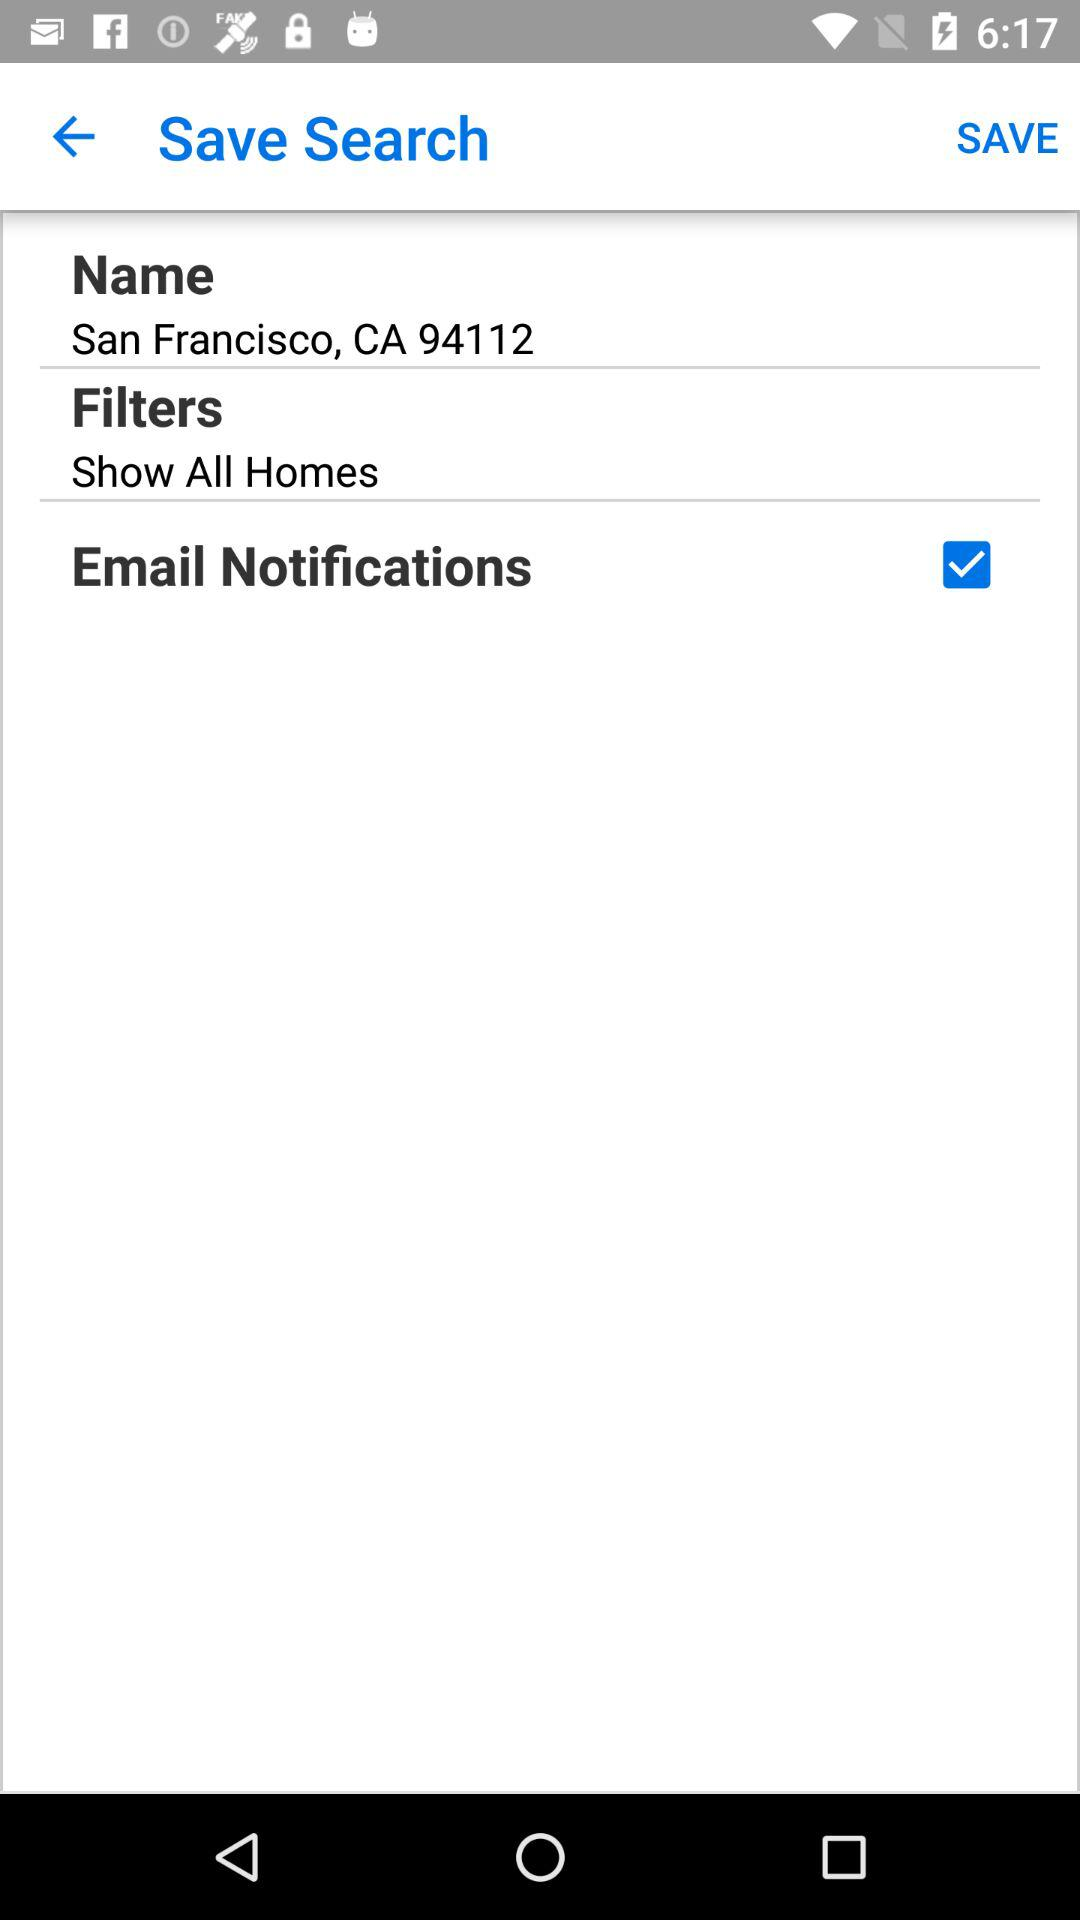What is the setting of filters? The setting for filters is "Show All Homes". 